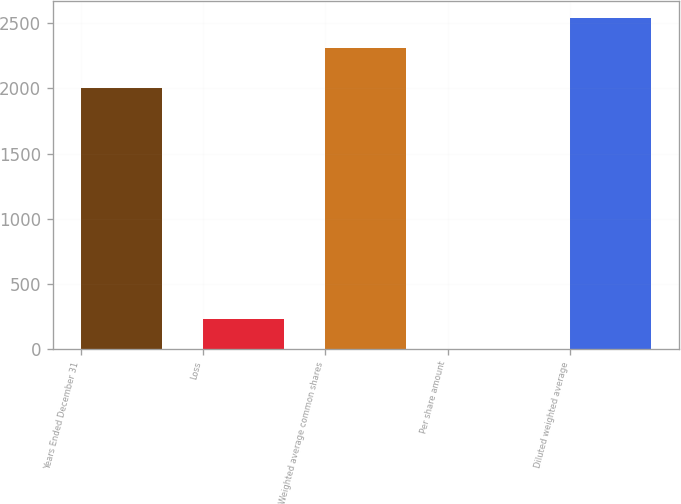<chart> <loc_0><loc_0><loc_500><loc_500><bar_chart><fcel>Years Ended December 31<fcel>Loss<fcel>Weighted average common shares<fcel>Per share amount<fcel>Diluted weighted average<nl><fcel>2007<fcel>231.31<fcel>2312.7<fcel>0.05<fcel>2543.96<nl></chart> 